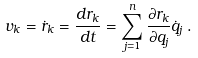<formula> <loc_0><loc_0><loc_500><loc_500>v _ { k } = { \dot { r } } _ { k } = { \frac { d r _ { k } } { d t } } = \sum _ { j = 1 } ^ { n } { \frac { \partial r _ { k } } { \partial q _ { j } } } { \dot { q } } _ { j } \, .</formula> 